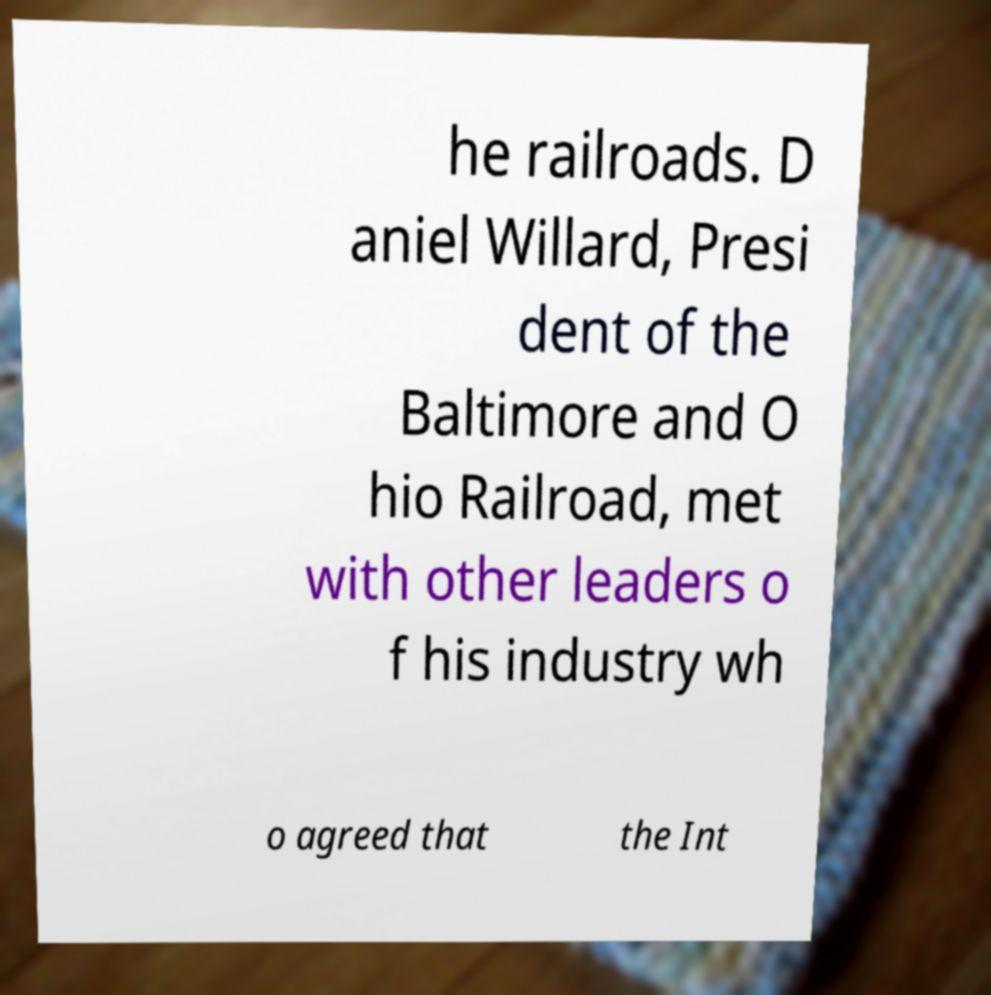I need the written content from this picture converted into text. Can you do that? he railroads. D aniel Willard, Presi dent of the Baltimore and O hio Railroad, met with other leaders o f his industry wh o agreed that the Int 